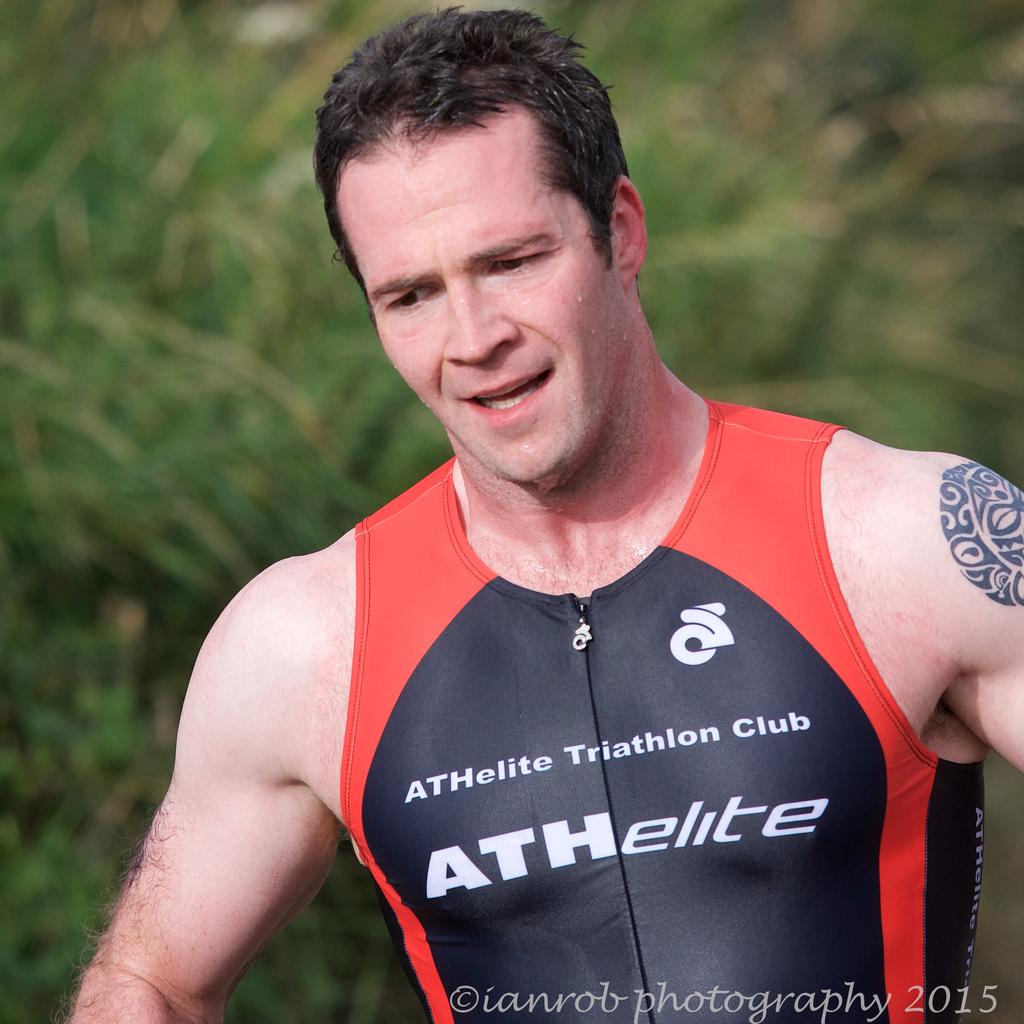<image>
Write a terse but informative summary of the picture. A man is wet and wearing a swimming suit that says Athelite Triathlon Club. 